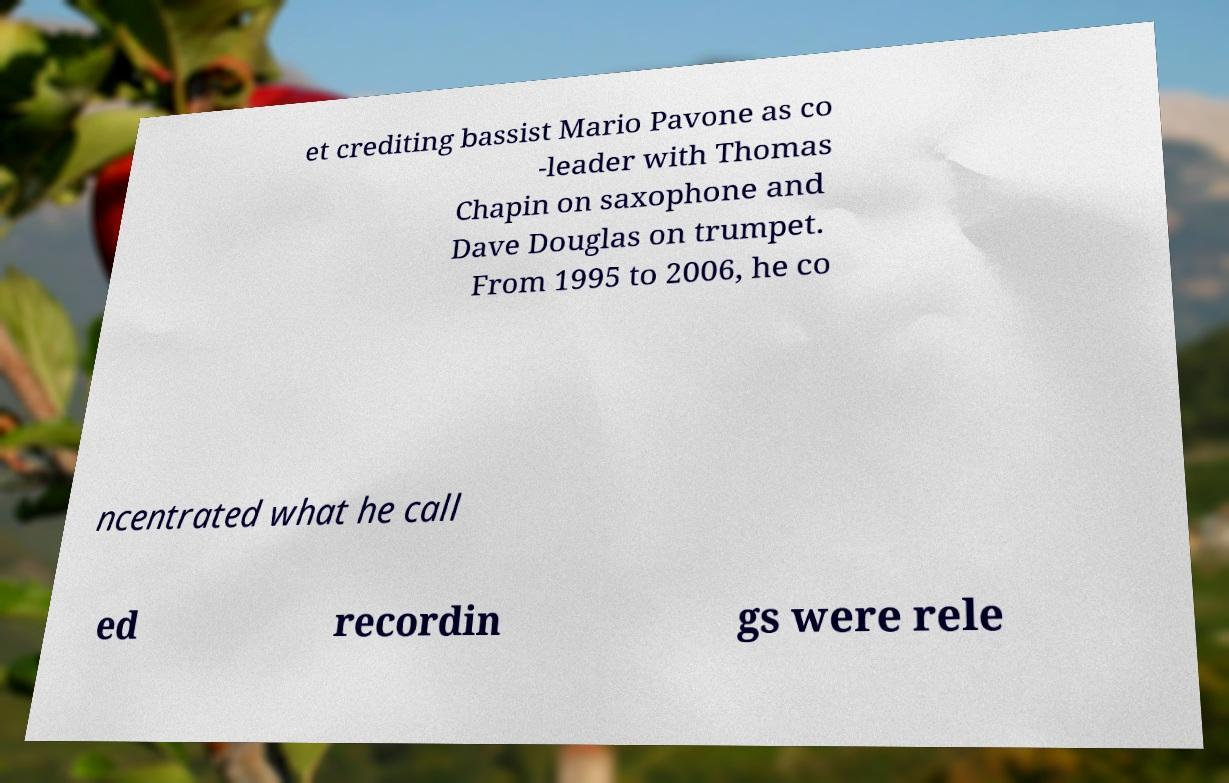Please read and relay the text visible in this image. What does it say? et crediting bassist Mario Pavone as co -leader with Thomas Chapin on saxophone and Dave Douglas on trumpet. From 1995 to 2006, he co ncentrated what he call ed recordin gs were rele 